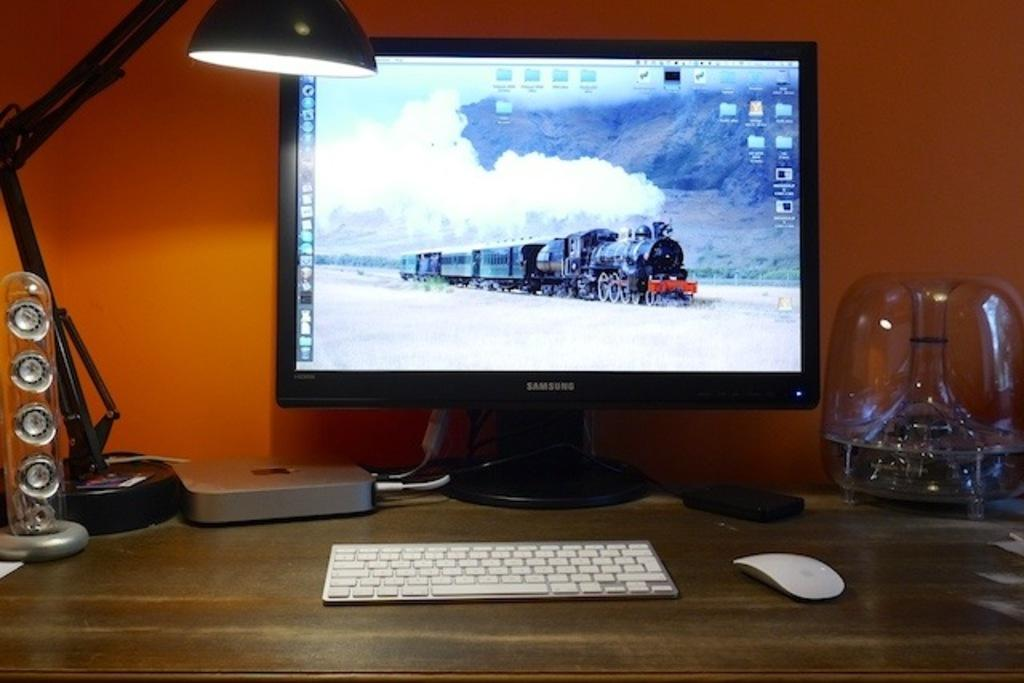<image>
Summarize the visual content of the image. A black Samsung brand computer monitore on a wood desk with a white keyboard and mouse. 